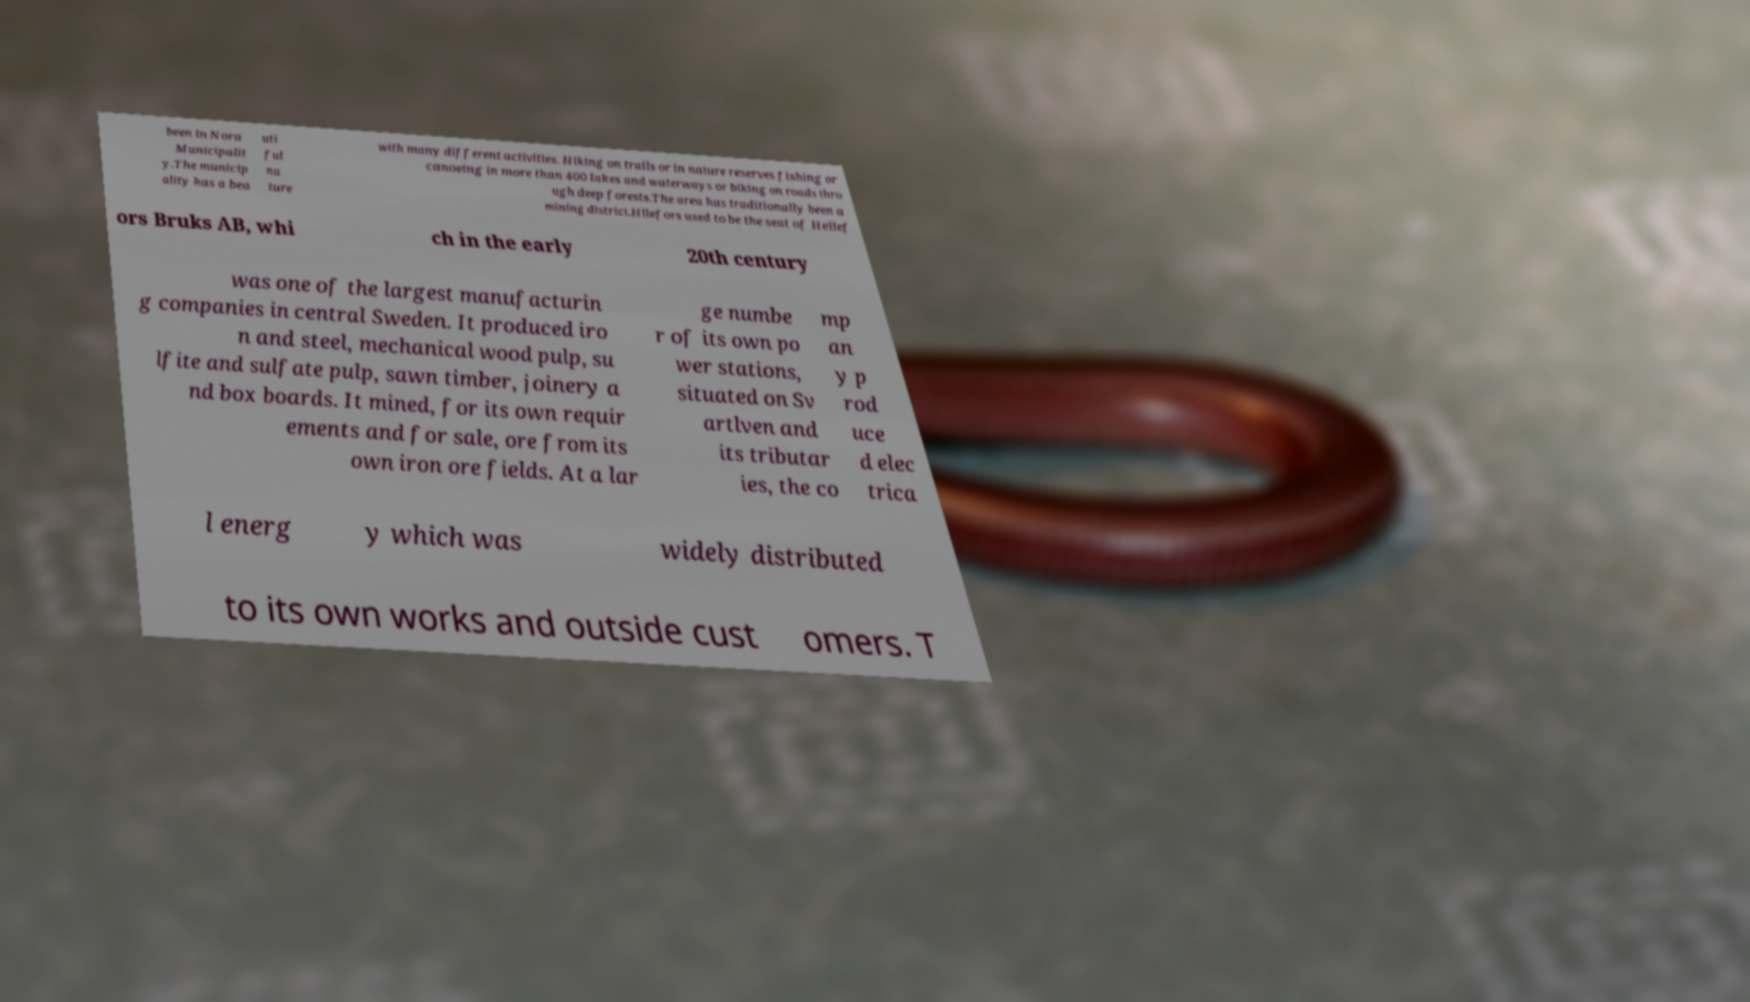Could you assist in decoding the text presented in this image and type it out clearly? been in Nora Municipalit y.The municip ality has a bea uti ful na ture with many different activities. Hiking on trails or in nature reserves fishing or canoeing in more than 400 lakes and waterways or biking on roads thro ugh deep forests.The area has traditionally been a mining district.Hllefors used to be the seat of Hellef ors Bruks AB, whi ch in the early 20th century was one of the largest manufacturin g companies in central Sweden. It produced iro n and steel, mechanical wood pulp, su lfite and sulfate pulp, sawn timber, joinery a nd box boards. It mined, for its own requir ements and for sale, ore from its own iron ore fields. At a lar ge numbe r of its own po wer stations, situated on Sv artlven and its tributar ies, the co mp an y p rod uce d elec trica l energ y which was widely distributed to its own works and outside cust omers. T 